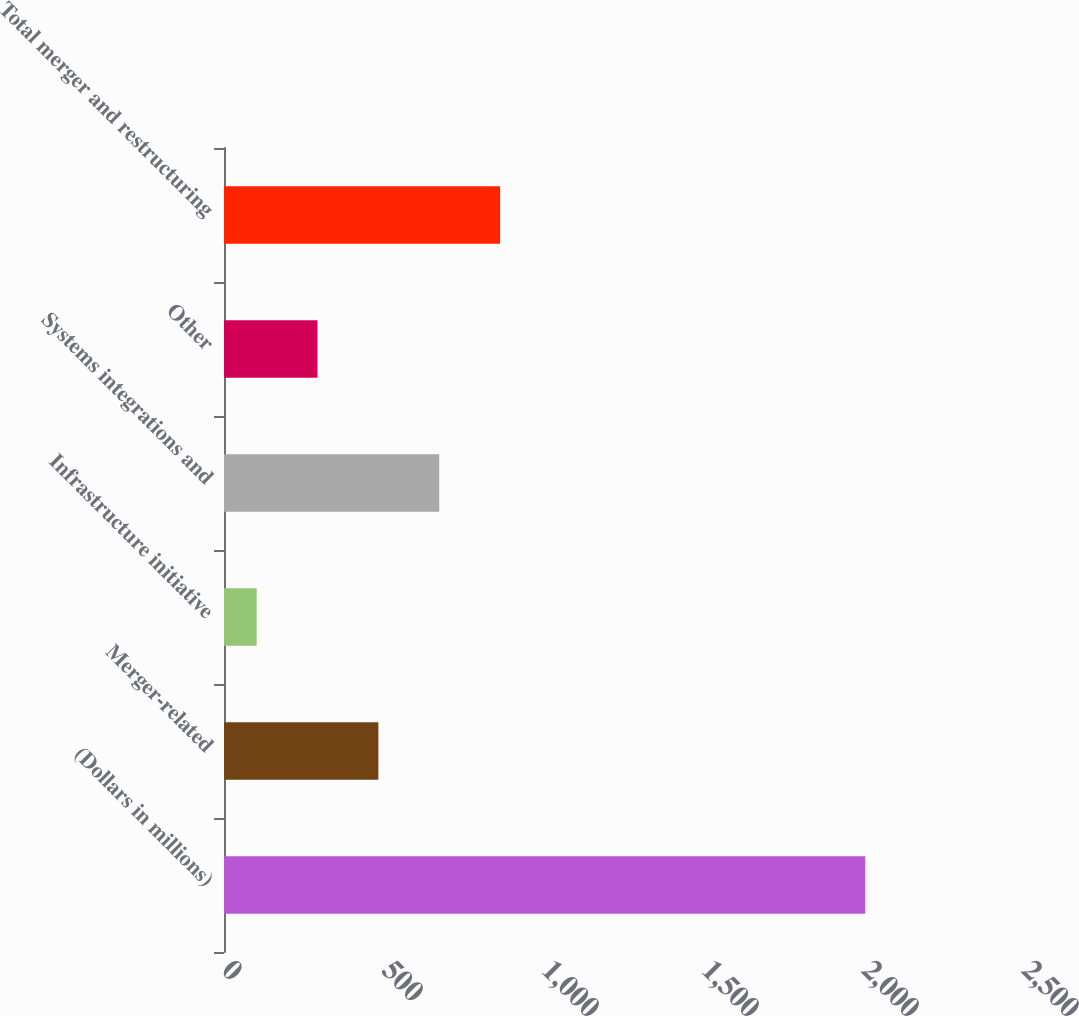Convert chart to OTSL. <chart><loc_0><loc_0><loc_500><loc_500><bar_chart><fcel>(Dollars in millions)<fcel>Merger-related<fcel>Infrastructure initiative<fcel>Systems integrations and<fcel>Other<fcel>Total merger and restructuring<nl><fcel>2004<fcel>482.4<fcel>102<fcel>672.6<fcel>292.2<fcel>862.8<nl></chart> 